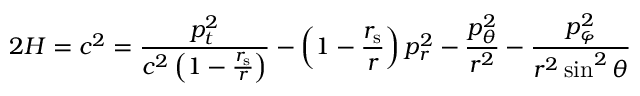Convert formula to latex. <formula><loc_0><loc_0><loc_500><loc_500>2 H = c ^ { 2 } = { \frac { p _ { t } ^ { 2 } } { c ^ { 2 } \left ( 1 - { \frac { r _ { s } } { r } } \right ) } } - \left ( 1 - { \frac { r _ { s } } { r } } \right ) p _ { r } ^ { 2 } - { \frac { p _ { \theta } ^ { 2 } } { r ^ { 2 } } } - { \frac { p _ { \varphi } ^ { 2 } } { r ^ { 2 } \sin ^ { 2 } \theta } }</formula> 